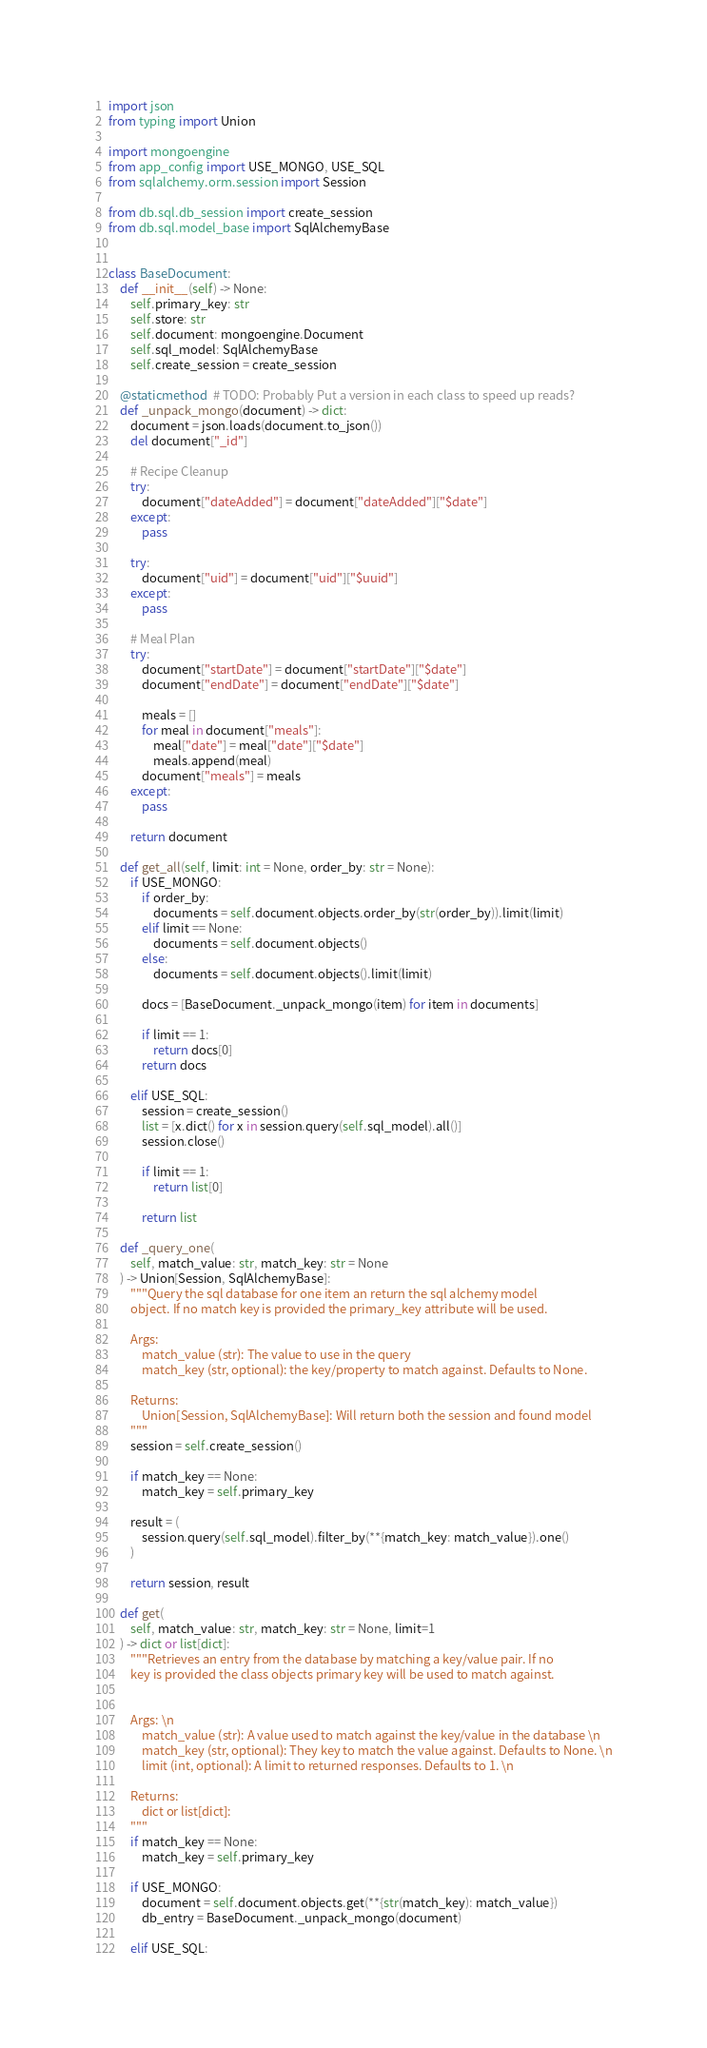<code> <loc_0><loc_0><loc_500><loc_500><_Python_>import json
from typing import Union

import mongoengine
from app_config import USE_MONGO, USE_SQL
from sqlalchemy.orm.session import Session

from db.sql.db_session import create_session
from db.sql.model_base import SqlAlchemyBase


class BaseDocument:
    def __init__(self) -> None:
        self.primary_key: str
        self.store: str
        self.document: mongoengine.Document
        self.sql_model: SqlAlchemyBase
        self.create_session = create_session

    @staticmethod  # TODO: Probably Put a version in each class to speed up reads?
    def _unpack_mongo(document) -> dict:
        document = json.loads(document.to_json())
        del document["_id"]

        # Recipe Cleanup
        try:
            document["dateAdded"] = document["dateAdded"]["$date"]
        except:
            pass

        try:
            document["uid"] = document["uid"]["$uuid"]
        except:
            pass

        # Meal Plan
        try:
            document["startDate"] = document["startDate"]["$date"]
            document["endDate"] = document["endDate"]["$date"]

            meals = []
            for meal in document["meals"]:
                meal["date"] = meal["date"]["$date"]
                meals.append(meal)
            document["meals"] = meals
        except:
            pass

        return document

    def get_all(self, limit: int = None, order_by: str = None):
        if USE_MONGO:
            if order_by:
                documents = self.document.objects.order_by(str(order_by)).limit(limit)
            elif limit == None:
                documents = self.document.objects()
            else:
                documents = self.document.objects().limit(limit)

            docs = [BaseDocument._unpack_mongo(item) for item in documents]

            if limit == 1:
                return docs[0]
            return docs

        elif USE_SQL:
            session = create_session()
            list = [x.dict() for x in session.query(self.sql_model).all()]
            session.close()

            if limit == 1:
                return list[0]

            return list

    def _query_one(
        self, match_value: str, match_key: str = None
    ) -> Union[Session, SqlAlchemyBase]:
        """Query the sql database for one item an return the sql alchemy model
        object. If no match key is provided the primary_key attribute will be used.

        Args:
            match_value (str): The value to use in the query
            match_key (str, optional): the key/property to match against. Defaults to None.

        Returns:
            Union[Session, SqlAlchemyBase]: Will return both the session and found model
        """
        session = self.create_session()

        if match_key == None:
            match_key = self.primary_key

        result = (
            session.query(self.sql_model).filter_by(**{match_key: match_value}).one()
        )

        return session, result

    def get(
        self, match_value: str, match_key: str = None, limit=1
    ) -> dict or list[dict]:
        """Retrieves an entry from the database by matching a key/value pair. If no
        key is provided the class objects primary key will be used to match against.


        Args: \n
            match_value (str): A value used to match against the key/value in the database \n
            match_key (str, optional): They key to match the value against. Defaults to None. \n
            limit (int, optional): A limit to returned responses. Defaults to 1. \n

        Returns:
            dict or list[dict]:
        """
        if match_key == None:
            match_key = self.primary_key

        if USE_MONGO:
            document = self.document.objects.get(**{str(match_key): match_value})
            db_entry = BaseDocument._unpack_mongo(document)

        elif USE_SQL:</code> 